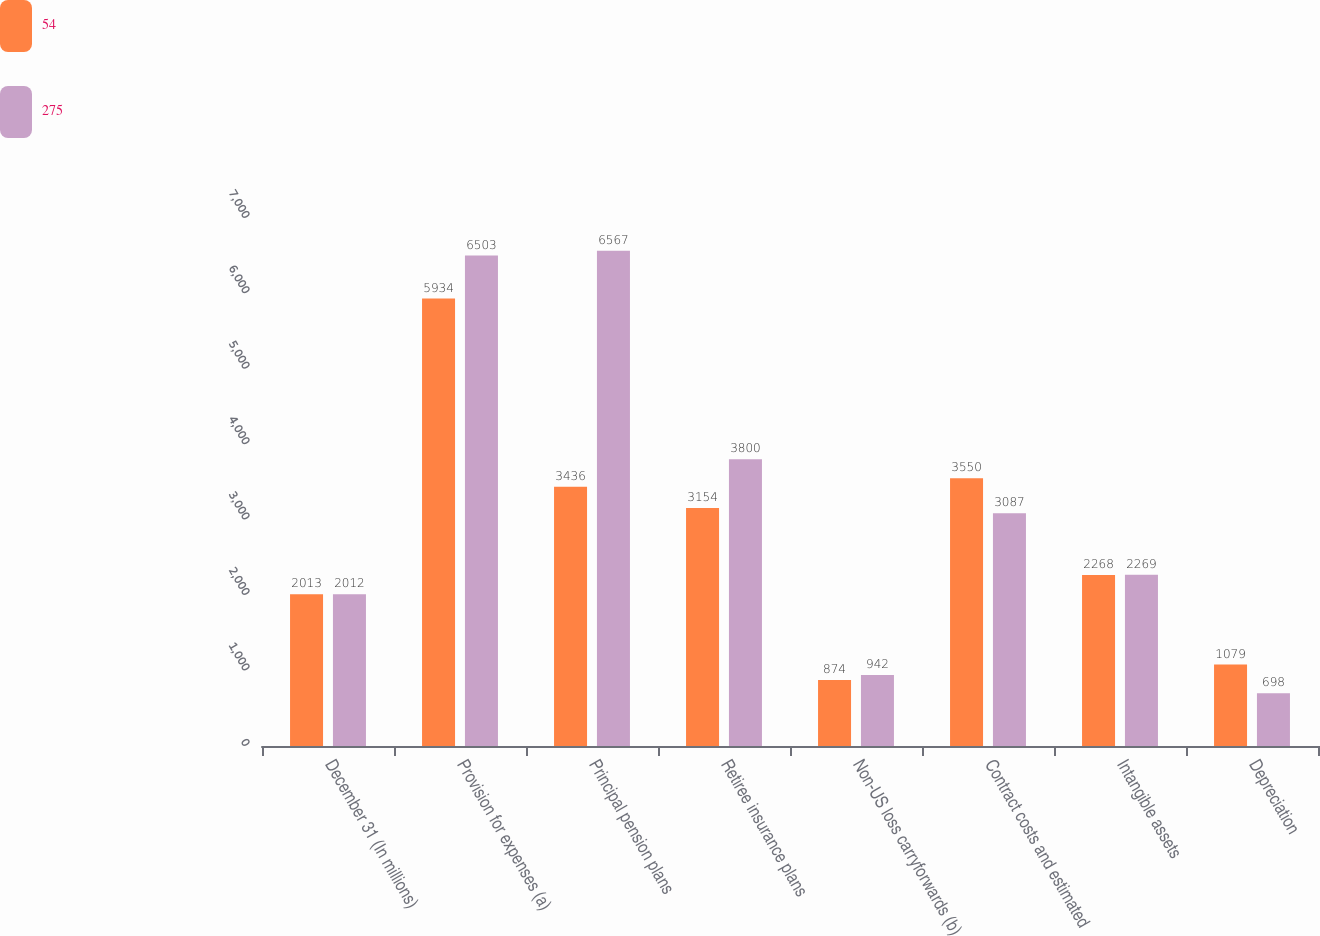Convert chart to OTSL. <chart><loc_0><loc_0><loc_500><loc_500><stacked_bar_chart><ecel><fcel>December 31 (In millions)<fcel>Provision for expenses (a)<fcel>Principal pension plans<fcel>Retiree insurance plans<fcel>Non-US loss carryforwards (b)<fcel>Contract costs and estimated<fcel>Intangible assets<fcel>Depreciation<nl><fcel>54<fcel>2013<fcel>5934<fcel>3436<fcel>3154<fcel>874<fcel>3550<fcel>2268<fcel>1079<nl><fcel>275<fcel>2012<fcel>6503<fcel>6567<fcel>3800<fcel>942<fcel>3087<fcel>2269<fcel>698<nl></chart> 